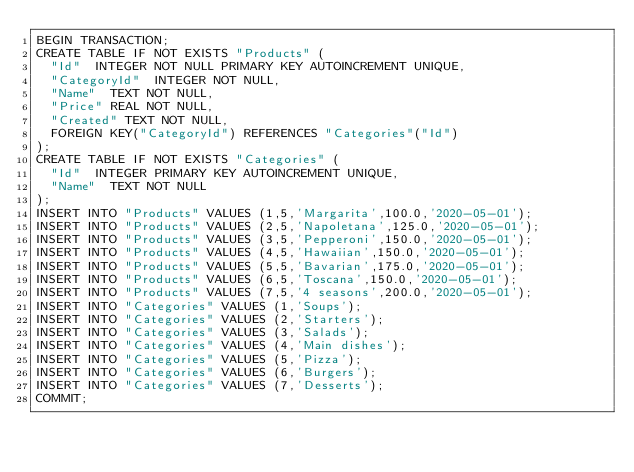<code> <loc_0><loc_0><loc_500><loc_500><_SQL_>BEGIN TRANSACTION;
CREATE TABLE IF NOT EXISTS "Products" (
	"Id"	INTEGER NOT NULL PRIMARY KEY AUTOINCREMENT UNIQUE,
	"CategoryId"	INTEGER NOT NULL,
	"Name"	TEXT NOT NULL,
	"Price"	REAL NOT NULL,
	"Created"	TEXT NOT NULL,
	FOREIGN KEY("CategoryId") REFERENCES "Categories"("Id")
);
CREATE TABLE IF NOT EXISTS "Categories" (
	"Id"	INTEGER PRIMARY KEY AUTOINCREMENT UNIQUE,
	"Name"	TEXT NOT NULL
);
INSERT INTO "Products" VALUES (1,5,'Margarita',100.0,'2020-05-01');
INSERT INTO "Products" VALUES (2,5,'Napoletana',125.0,'2020-05-01');
INSERT INTO "Products" VALUES (3,5,'Pepperoni',150.0,'2020-05-01');
INSERT INTO "Products" VALUES (4,5,'Hawaiian',150.0,'2020-05-01');
INSERT INTO "Products" VALUES (5,5,'Bavarian',175.0,'2020-05-01');
INSERT INTO "Products" VALUES (6,5,'Toscana',150.0,'2020-05-01');
INSERT INTO "Products" VALUES (7,5,'4 seasons',200.0,'2020-05-01');
INSERT INTO "Categories" VALUES (1,'Soups');
INSERT INTO "Categories" VALUES (2,'Starters');
INSERT INTO "Categories" VALUES (3,'Salads');
INSERT INTO "Categories" VALUES (4,'Main dishes');
INSERT INTO "Categories" VALUES (5,'Pizza');
INSERT INTO "Categories" VALUES (6,'Burgers');
INSERT INTO "Categories" VALUES (7,'Desserts');
COMMIT;
</code> 